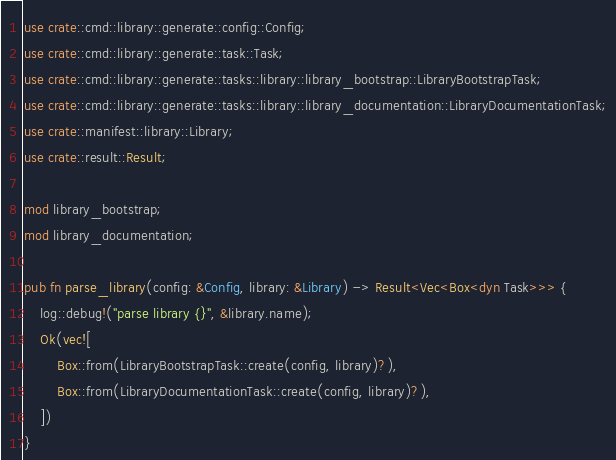Convert code to text. <code><loc_0><loc_0><loc_500><loc_500><_Rust_>use crate::cmd::library::generate::config::Config;
use crate::cmd::library::generate::task::Task;
use crate::cmd::library::generate::tasks::library::library_bootstrap::LibraryBootstrapTask;
use crate::cmd::library::generate::tasks::library::library_documentation::LibraryDocumentationTask;
use crate::manifest::library::Library;
use crate::result::Result;

mod library_bootstrap;
mod library_documentation;

pub fn parse_library(config: &Config, library: &Library) -> Result<Vec<Box<dyn Task>>> {
    log::debug!("parse library {}", &library.name);
    Ok(vec![
        Box::from(LibraryBootstrapTask::create(config, library)?),
        Box::from(LibraryDocumentationTask::create(config, library)?),
    ])
}
</code> 